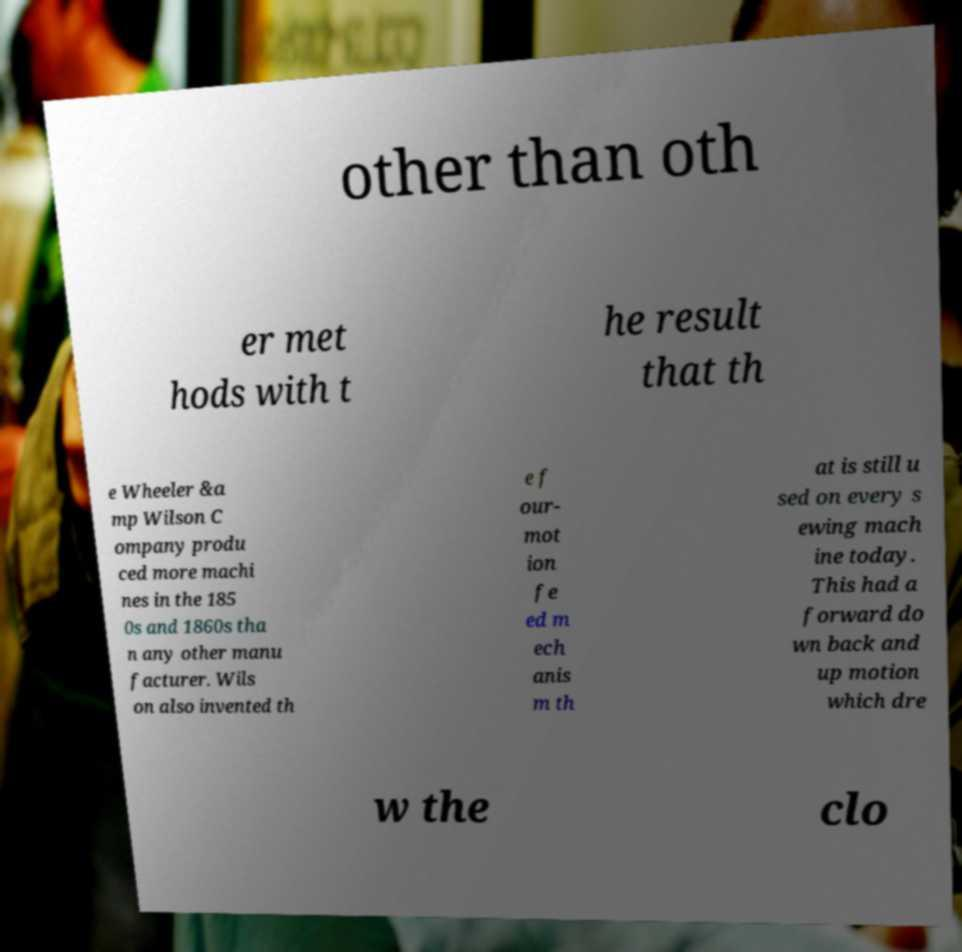Can you accurately transcribe the text from the provided image for me? other than oth er met hods with t he result that th e Wheeler &a mp Wilson C ompany produ ced more machi nes in the 185 0s and 1860s tha n any other manu facturer. Wils on also invented th e f our- mot ion fe ed m ech anis m th at is still u sed on every s ewing mach ine today. This had a forward do wn back and up motion which dre w the clo 